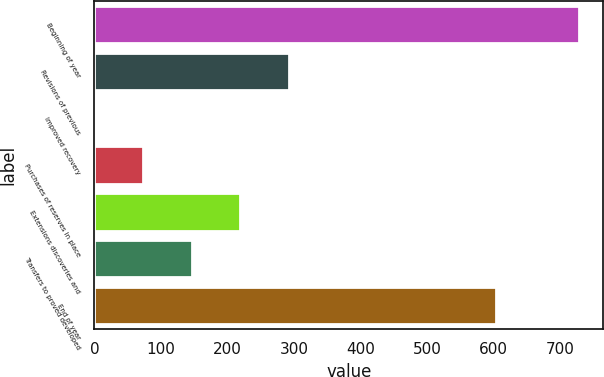Convert chart. <chart><loc_0><loc_0><loc_500><loc_500><bar_chart><fcel>Beginning of year<fcel>Revisions of previous<fcel>Improved recovery<fcel>Purchases of reserves in place<fcel>Extensions discoveries and<fcel>Transfers to proved developed<fcel>End of year<nl><fcel>728<fcel>291.8<fcel>1<fcel>73.7<fcel>219.1<fcel>146.4<fcel>603<nl></chart> 